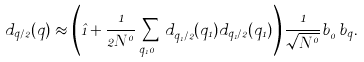<formula> <loc_0><loc_0><loc_500><loc_500>d _ { { q } / 2 } ( { q } ) \approx \left ( { \hat { 1 } } + \frac { 1 } { 2 N ^ { 0 } } \sum _ { { q } _ { 1 } \neq 0 } d ^ { \dagger } _ { { q } _ { 1 } / 2 } ( { q } _ { 1 } ) d _ { { q } _ { 1 } / 2 } ( { q } _ { 1 } ) \right ) \frac { 1 } { \sqrt { N ^ { 0 } } } b ^ { \dagger } _ { 0 } b _ { q } .</formula> 